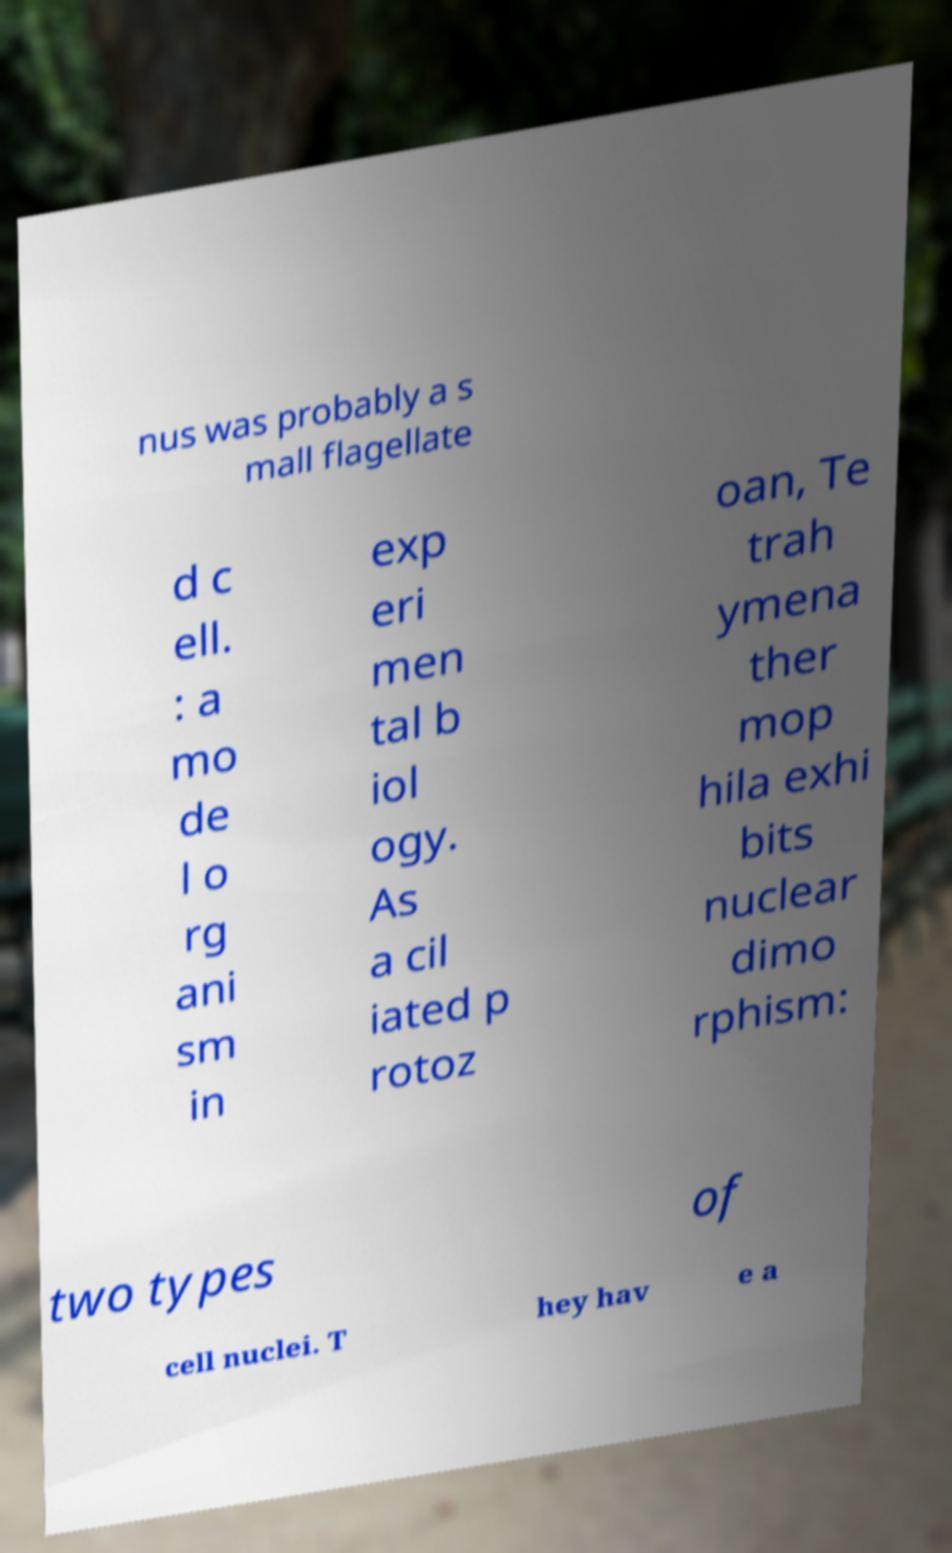There's text embedded in this image that I need extracted. Can you transcribe it verbatim? nus was probably a s mall flagellate d c ell. : a mo de l o rg ani sm in exp eri men tal b iol ogy. As a cil iated p rotoz oan, Te trah ymena ther mop hila exhi bits nuclear dimo rphism: two types of cell nuclei. T hey hav e a 